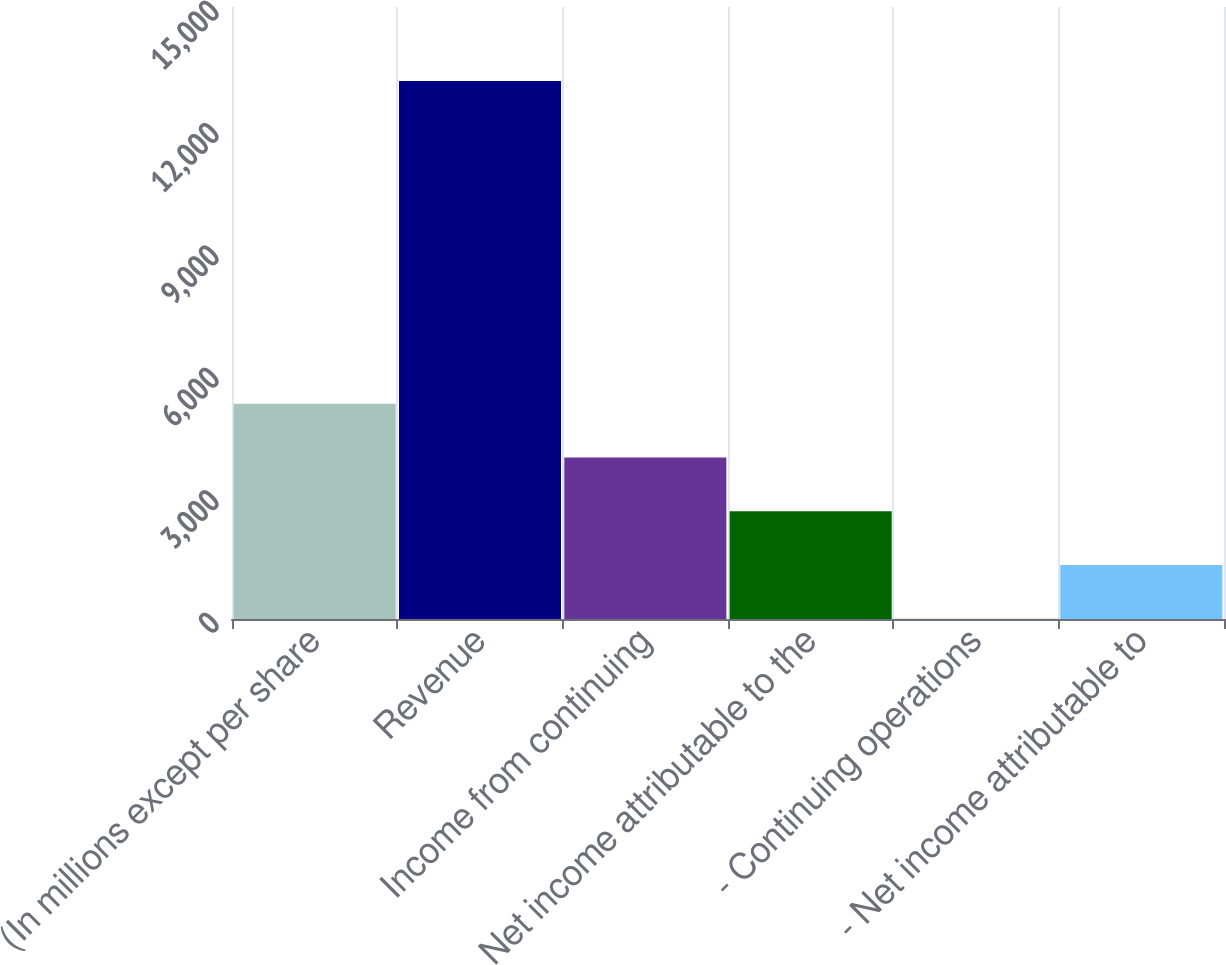<chart> <loc_0><loc_0><loc_500><loc_500><bar_chart><fcel>(In millions except per share<fcel>Revenue<fcel>Income from continuing<fcel>Net income attributable to the<fcel>- Continuing operations<fcel>- Net income attributable to<nl><fcel>5275.85<fcel>13185<fcel>3957.66<fcel>2639.47<fcel>3.09<fcel>1321.28<nl></chart> 